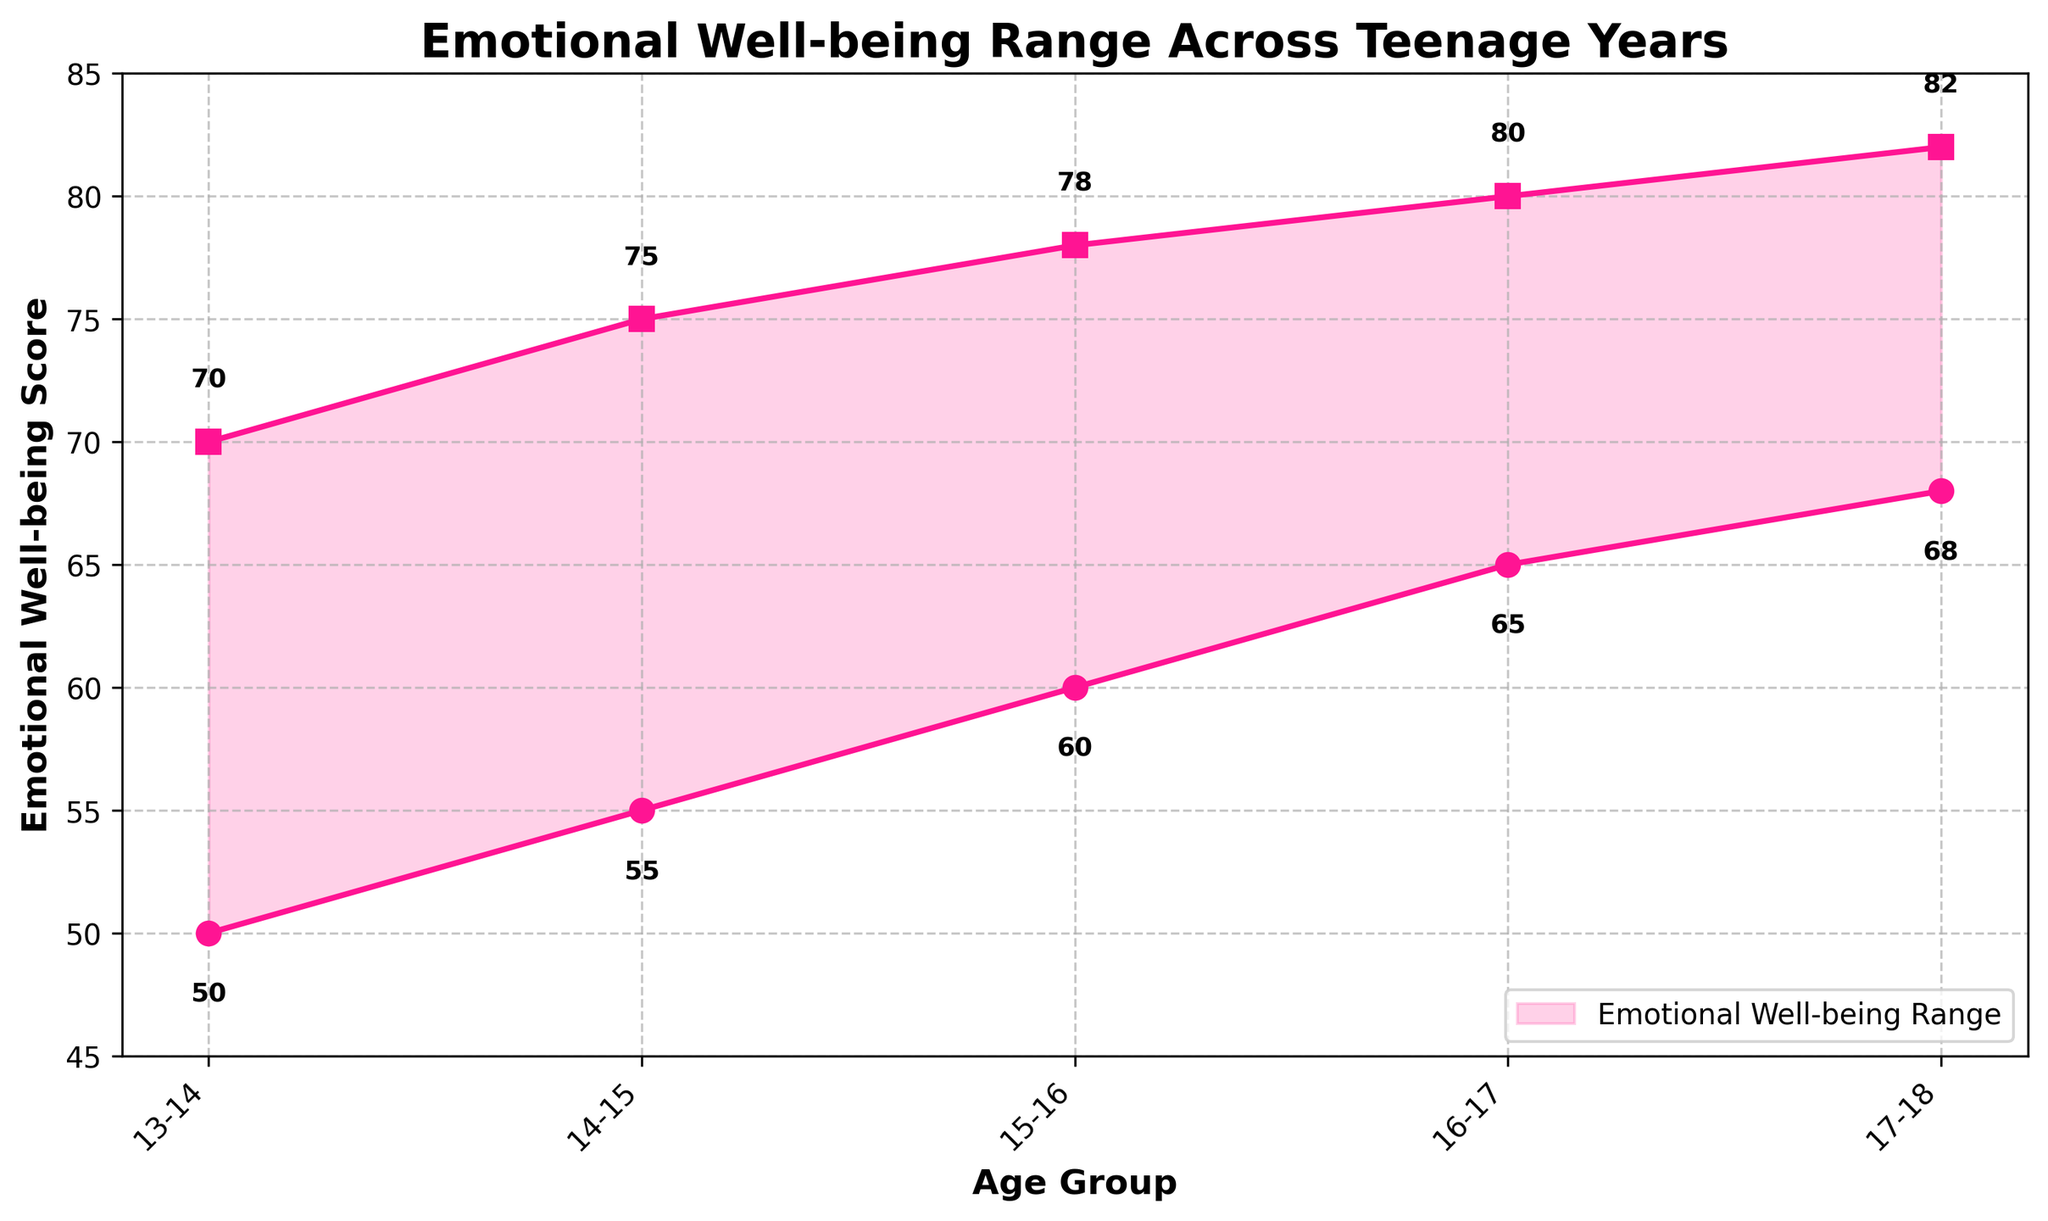What is the title of the chart? The chart title can be found at the top of the figure. The title reads "Emotional Well-being Range Across Teenage Years"
Answer: Emotional Well-being Range Across Teenage Years What age group shows the highest maximum emotional well-being score? To find this, we look for the highest point on the upper line of the range area chart. The highest maximum well-being score is 82, which corresponds to the 17-18 age group.
Answer: 17-18 What is the minimum emotional well-being score for the 14-15 age group? Look at the data point on the bottom line (min score) for the 14-15 age group. The score listed is 55.
Answer: 55 How does the range of emotional well-being scores change from the 13-14 to 17-18 age groups? Observe the fill area between the min and max scores over time. Initially, the range is 20 (70 - 50 = 20) for the 13-14 age group. This range narrows slightly to 14 (82 - 68 = 14) for the 17-18 age group. Therefore, the range slightly decreases.
Answer: Decreases Which age group has the smallest difference between its minimum and maximum emotional well-being scores? Calculate the differences for each age group: \[13-14: 70-50=20\], \[14-15: 75-55=20\], \[15-16: 78-60=18\], \[16-17: 80-65=15\], \[17-18: 82-68=14\]. Thus, the 17-18 age group has the smallest range, which is 14.
Answer: 17-18 What is the trend in the minimum emotional well-being scores across age groups? Track the points on the bottom line representing the min scores. It starts from 50 at age 13-14 and steadily rises to 68 at age 17-18. Thus, the trend in minimum scores is increasing.
Answer: Increasing Which age group has a higher minimum emotional well-being score: 15-16 or 16-17? Compare the minimum scores for the two groups. 15-16 has a score of 60, while 16-17 has a score of 65. Therefore, 16-17 is higher.
Answer: 16-17 How much does the maximum emotional well-being score increase between the 14-15 and 16-17 age groups? Find the difference between the maximum scores of the two groups. 16-17 has a max score of 80, and 14-15 has a max score of 75. So, the increase is 80 - 75 = 5.
Answer: 5 What is the total range of emotional well-being scores covered in the chart? Determine the overall range by finding the difference between the highest maximum and the lowest minimum scores. The highest max is 82 and the lowest min is 50, so the overall range is 82 - 50 = 32.
Answer: 32 